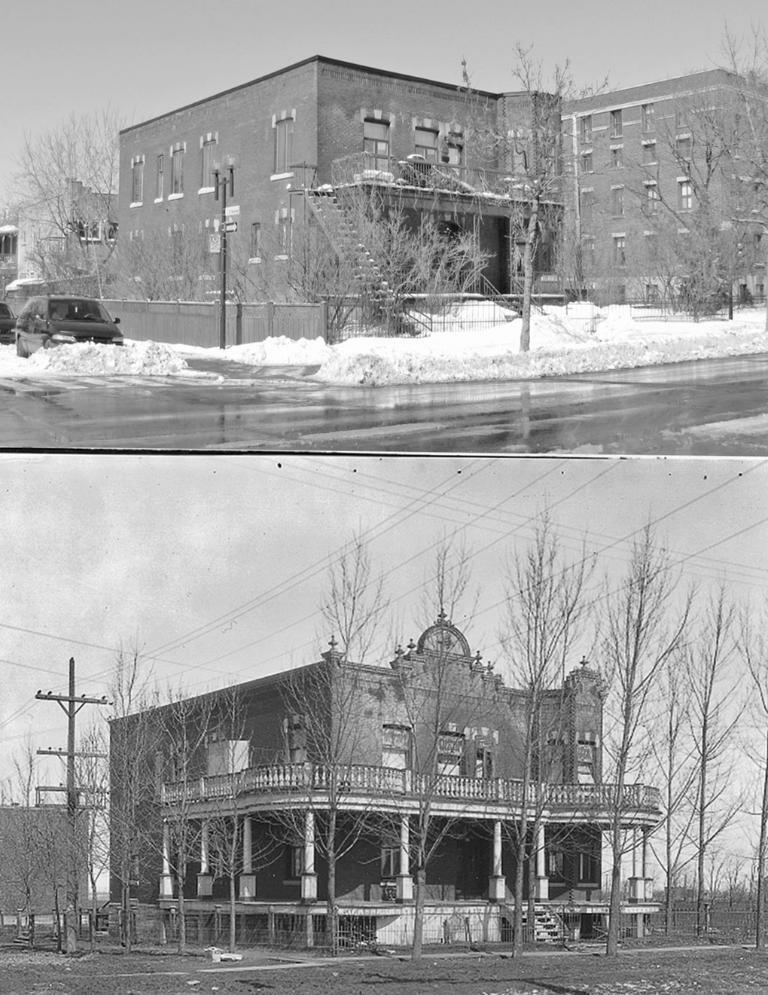How would you summarize this image in a sentence or two? It is a collage picture. In these pictures, we can see houses with wall, glass windows and stairs. At the bottom, we can so many trees, pillars, pole with wires. Background there is a sky. Top of the image, we can see a road, snow. Here there is a trees, vehicle and sky. 